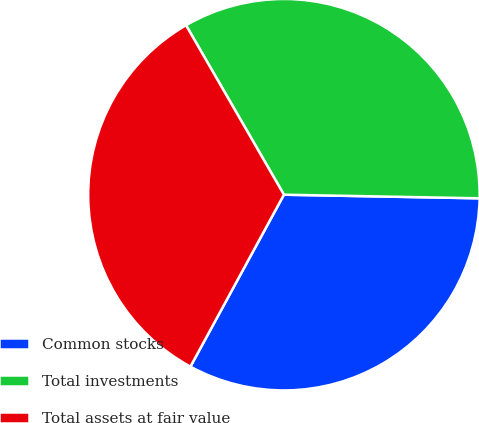<chart> <loc_0><loc_0><loc_500><loc_500><pie_chart><fcel>Common stocks<fcel>Total investments<fcel>Total assets at fair value<nl><fcel>32.63%<fcel>33.63%<fcel>33.73%<nl></chart> 